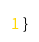Convert code to text. <code><loc_0><loc_0><loc_500><loc_500><_C++_>

}
</code> 